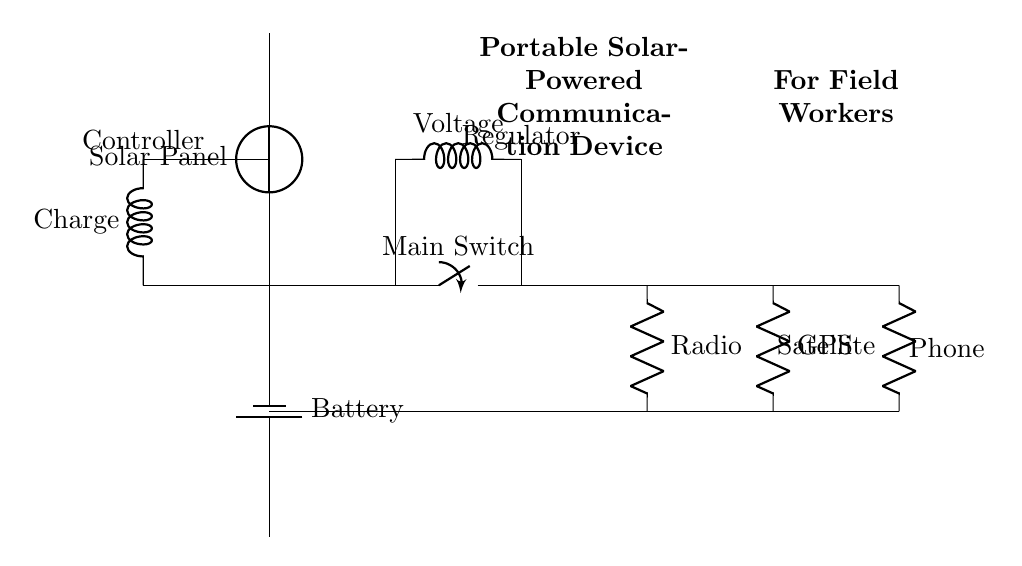What type of circuit is this? The circuit is a parallel circuit, as all the components (radio, GPS, and satellite phone) are connected in parallel to the power source, allowing them to operate independently.
Answer: Parallel How many branches are there in this circuit? There are three branches originating from the main switch: one for the radio, one for the GPS, and one for the satellite phone. Each branch allows for independent operation.
Answer: Three What is the function of the voltage regulator? The voltage regulator ensures that a consistent voltage is supplied to the devices, specifically adjusting the voltage down to a safe level for the radio, GPS, and satellite phone.
Answer: Regulate voltage Which component prevents overcharging of the battery? The charge controller is responsible for regulating the charge level to prevent overcharging of the battery, ensuring that the battery remains within safe limits.
Answer: Charge controller What happens when the main switch is turned off? Turning off the main switch disconnects all branches, meaning no power is supplied to any of the devices, effectively shutting them down.
Answer: No power Which component allows the system to receive solar energy? The solar panel is the component that captures solar energy and converts it into electrical energy for the system to operate.
Answer: Solar panel 